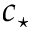<formula> <loc_0><loc_0><loc_500><loc_500>c _ { ^ { * } }</formula> 